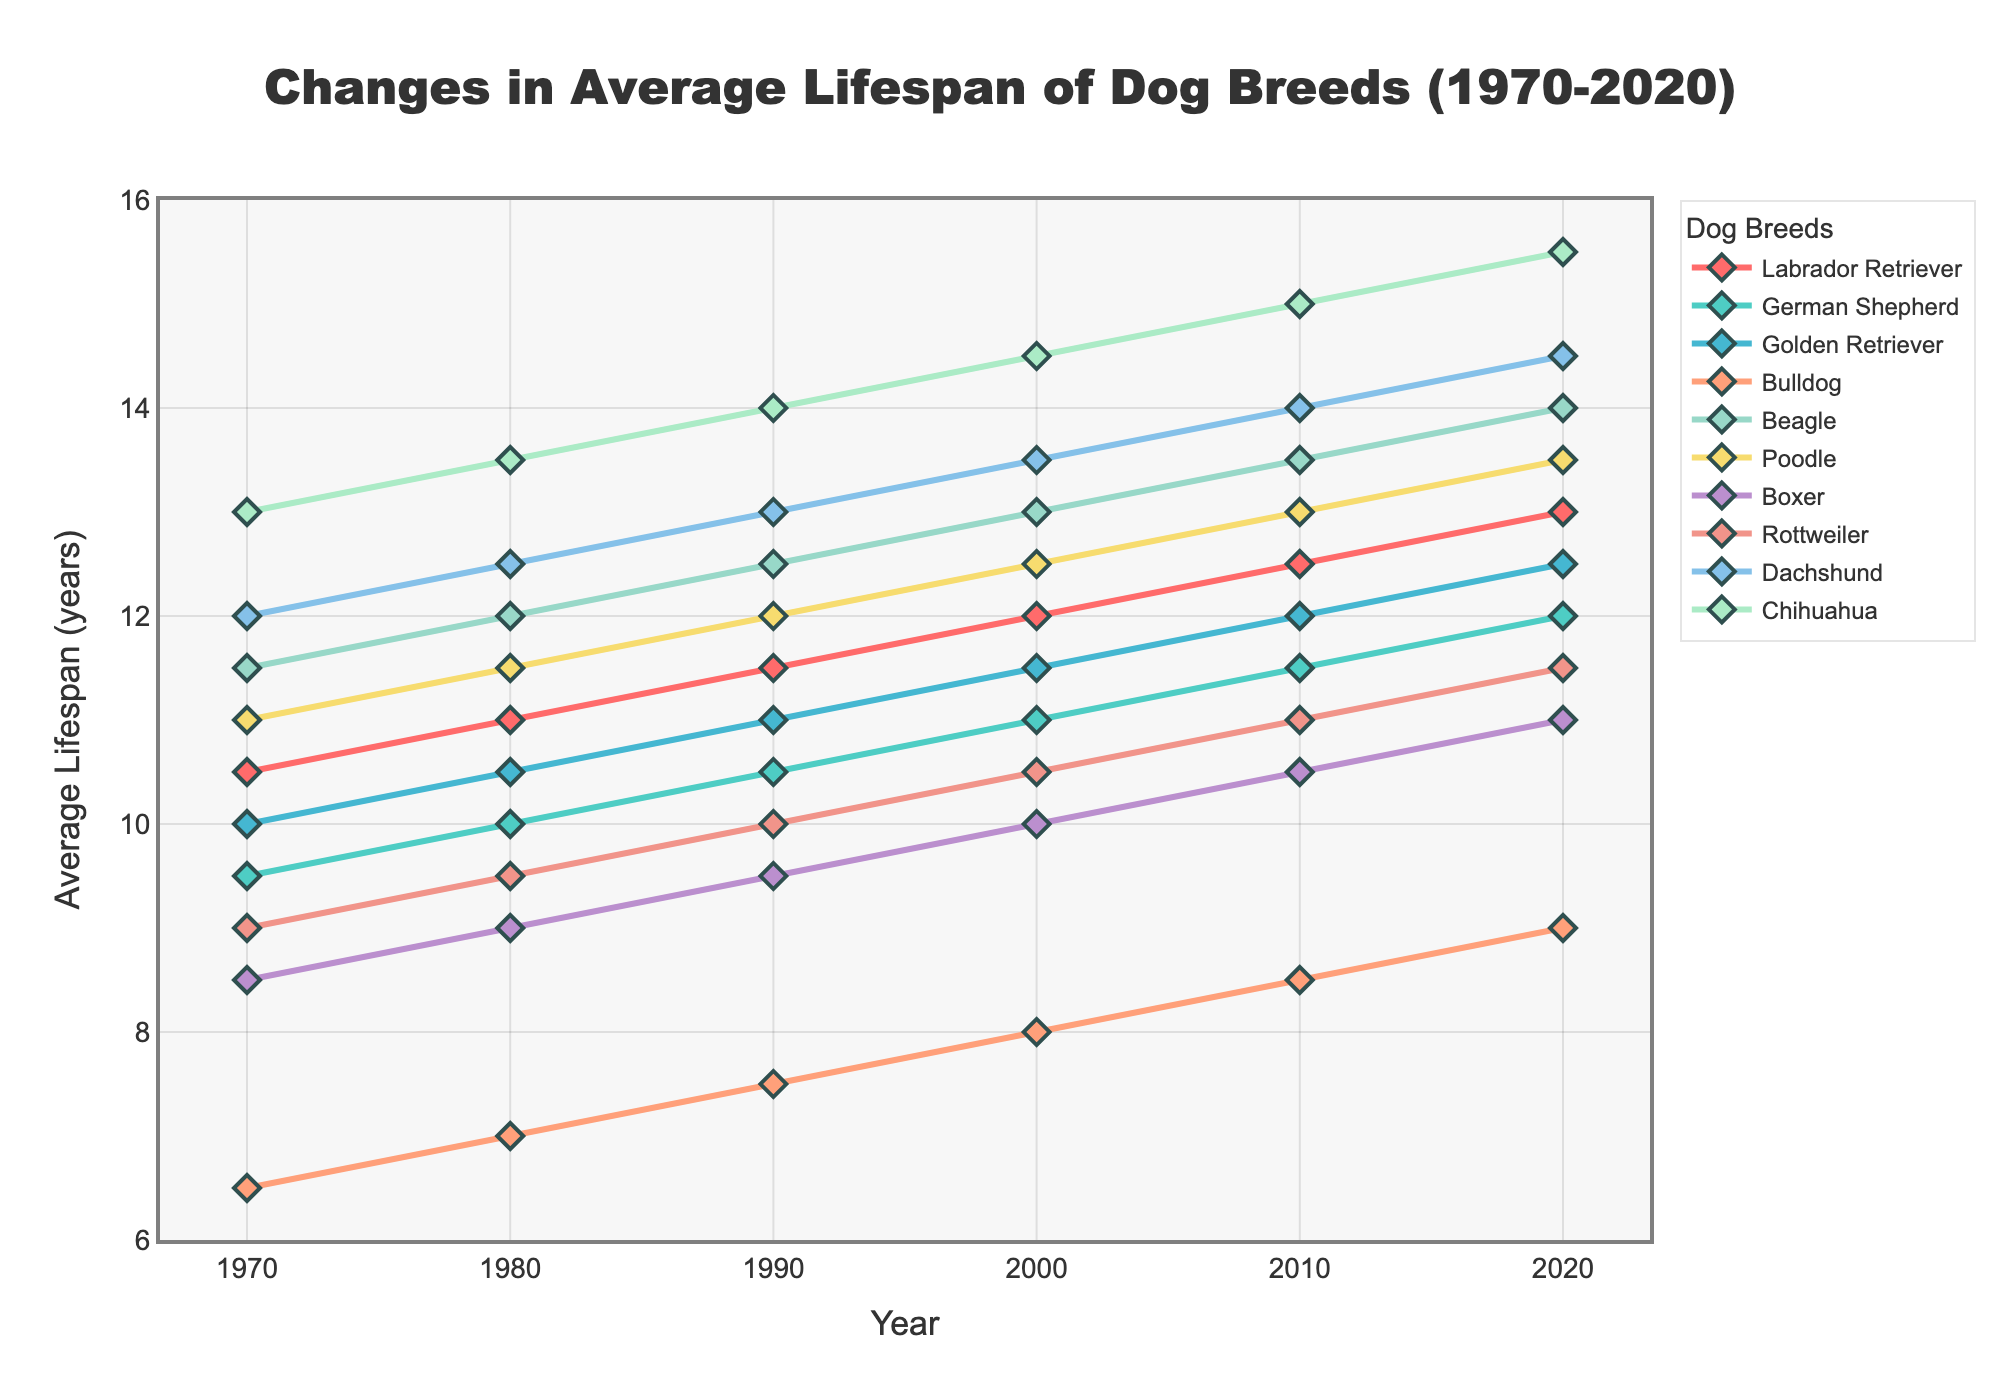Which breed has the longest average lifespan in 2020? We look for the breed with the highest value on the y-axis in 2020. Chihuahua has the longest average lifespan in 2020, which is 15.5 years.
Answer: Chihuahua What is the difference in the average lifespan between a Bulldog and a Beagle in 1990? The Bulldog's average lifespan in 1990 is 7.5 years, and the Beagle's average lifespan is 12.5 years. The difference is 12.5 - 7.5 = 5 years.
Answer: 5 years Compare the growth in average lifespan from 1970 to 2020 between a Boxer and a Poodle. Which breed has shown a greater increase? The Boxer's lifespan increased from 8.5 years in 1970 to 11.0 years in 2020, an increase of 2.5 years. The Poodle's lifespan increased from 11.0 years to 13.5 years, an increase of 2.5 years. Both breeds show the same increase.
Answer: Both equal Which breed had the fastest increase in average lifespan between 1980 and 1990? We look at the difference in lifespan between 1980 and 1990 for each breed. The largest increase is for Chihuahua, which increased from 13.5 to 14.0 years (0.5 years).
Answer: Chihuahua What is the trend in average lifespan for Rottweilers from 1970 to 2020? The trend can be observed by looking at the line for Rottweilers. The lifespan consistently increases from 9.0 years in 1970 to 11.5 years in 2020, showing a steady upward trend.
Answer: Steady upward trend Identify the breed with the shortest lifespan in 1980 and compare it with the shortest lifespan breed in 2020. Are they the same? In 1980, the breed with the shortest lifespan is Bulldog (7.0 years). In 2020, it is also Bulldog (9.0 years). Yes, they are the same.
Answer: Yes How does the average lifespan of Golden Retrievers in 1980 compare to that of Labradors in 1990? The average lifespan for Golden Retrievers in 1980 is 10.5 years. For Labradors in 1990, it is 11.5 years. Therefore, Labradors in 1990 had a longer lifespan than Golden Retrievers in 1980 by 1 year.
Answer: Labradors longer by 1 year 